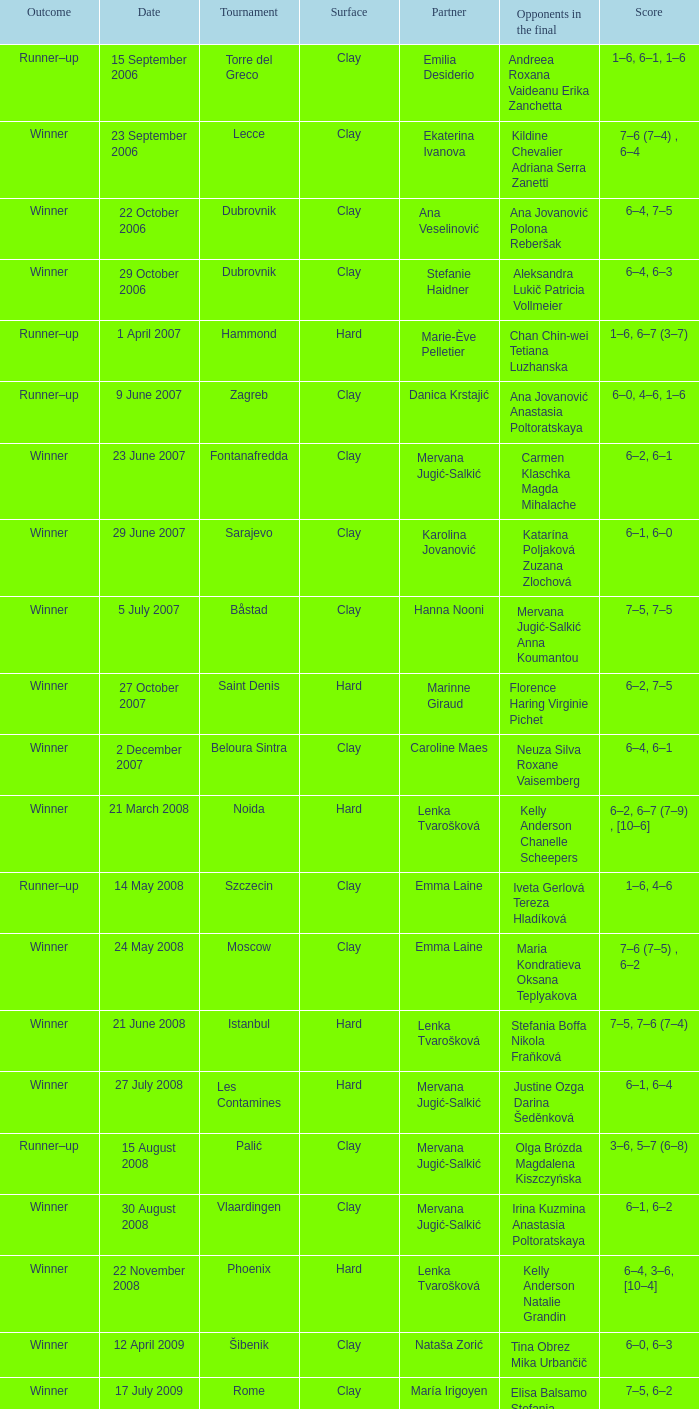In which competition did erika sema's partner participate? Aschaffenburg. 